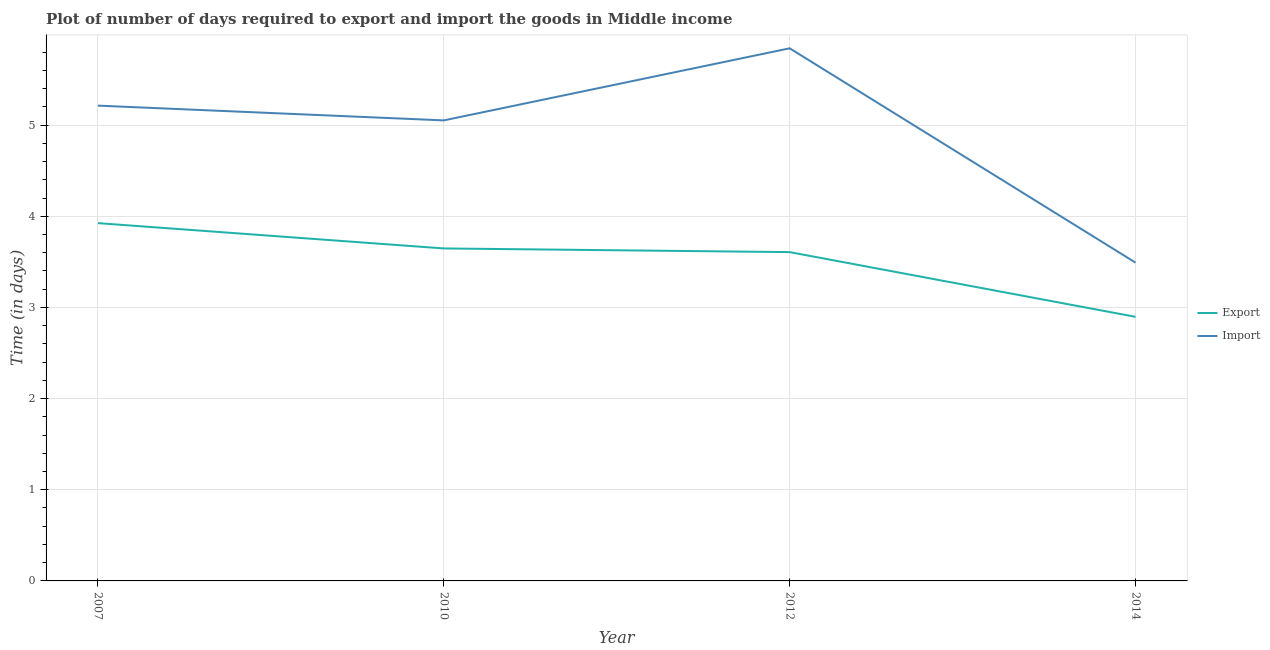How many different coloured lines are there?
Offer a terse response. 2. Is the number of lines equal to the number of legend labels?
Provide a succinct answer. Yes. What is the time required to import in 2010?
Give a very brief answer. 5.05. Across all years, what is the maximum time required to export?
Offer a very short reply. 3.92. Across all years, what is the minimum time required to export?
Offer a very short reply. 2.9. In which year was the time required to import maximum?
Offer a terse response. 2012. In which year was the time required to export minimum?
Make the answer very short. 2014. What is the total time required to export in the graph?
Ensure brevity in your answer.  14.07. What is the difference between the time required to export in 2007 and that in 2010?
Provide a succinct answer. 0.28. What is the difference between the time required to export in 2014 and the time required to import in 2010?
Your answer should be compact. -2.15. What is the average time required to import per year?
Keep it short and to the point. 4.9. In the year 2012, what is the difference between the time required to export and time required to import?
Ensure brevity in your answer.  -2.24. What is the ratio of the time required to export in 2007 to that in 2012?
Your answer should be compact. 1.09. Is the time required to import in 2010 less than that in 2012?
Keep it short and to the point. Yes. What is the difference between the highest and the second highest time required to import?
Make the answer very short. 0.63. What is the difference between the highest and the lowest time required to import?
Your response must be concise. 2.35. Is the time required to export strictly greater than the time required to import over the years?
Provide a short and direct response. No. Is the time required to export strictly less than the time required to import over the years?
Make the answer very short. Yes. How many lines are there?
Offer a very short reply. 2. What is the difference between two consecutive major ticks on the Y-axis?
Your answer should be very brief. 1. Are the values on the major ticks of Y-axis written in scientific E-notation?
Provide a short and direct response. No. Does the graph contain any zero values?
Ensure brevity in your answer.  No. Where does the legend appear in the graph?
Your answer should be compact. Center right. How many legend labels are there?
Offer a very short reply. 2. How are the legend labels stacked?
Offer a very short reply. Vertical. What is the title of the graph?
Your answer should be very brief. Plot of number of days required to export and import the goods in Middle income. What is the label or title of the X-axis?
Provide a short and direct response. Year. What is the label or title of the Y-axis?
Keep it short and to the point. Time (in days). What is the Time (in days) in Export in 2007?
Give a very brief answer. 3.92. What is the Time (in days) in Import in 2007?
Your answer should be very brief. 5.21. What is the Time (in days) in Export in 2010?
Make the answer very short. 3.65. What is the Time (in days) in Import in 2010?
Make the answer very short. 5.05. What is the Time (in days) in Export in 2012?
Your response must be concise. 3.61. What is the Time (in days) of Import in 2012?
Keep it short and to the point. 5.84. What is the Time (in days) of Export in 2014?
Your answer should be very brief. 2.9. What is the Time (in days) of Import in 2014?
Your response must be concise. 3.49. Across all years, what is the maximum Time (in days) in Export?
Ensure brevity in your answer.  3.92. Across all years, what is the maximum Time (in days) of Import?
Your response must be concise. 5.84. Across all years, what is the minimum Time (in days) in Export?
Ensure brevity in your answer.  2.9. Across all years, what is the minimum Time (in days) in Import?
Provide a short and direct response. 3.49. What is the total Time (in days) of Export in the graph?
Provide a short and direct response. 14.07. What is the total Time (in days) of Import in the graph?
Provide a short and direct response. 19.6. What is the difference between the Time (in days) of Export in 2007 and that in 2010?
Make the answer very short. 0.28. What is the difference between the Time (in days) in Import in 2007 and that in 2010?
Your answer should be compact. 0.16. What is the difference between the Time (in days) in Export in 2007 and that in 2012?
Offer a terse response. 0.32. What is the difference between the Time (in days) of Import in 2007 and that in 2012?
Give a very brief answer. -0.63. What is the difference between the Time (in days) of Export in 2007 and that in 2014?
Provide a succinct answer. 1.03. What is the difference between the Time (in days) in Import in 2007 and that in 2014?
Give a very brief answer. 1.72. What is the difference between the Time (in days) in Export in 2010 and that in 2012?
Provide a short and direct response. 0.04. What is the difference between the Time (in days) in Import in 2010 and that in 2012?
Make the answer very short. -0.79. What is the difference between the Time (in days) of Export in 2010 and that in 2014?
Offer a terse response. 0.75. What is the difference between the Time (in days) in Import in 2010 and that in 2014?
Offer a terse response. 1.56. What is the difference between the Time (in days) in Export in 2012 and that in 2014?
Provide a short and direct response. 0.71. What is the difference between the Time (in days) of Import in 2012 and that in 2014?
Your response must be concise. 2.35. What is the difference between the Time (in days) in Export in 2007 and the Time (in days) in Import in 2010?
Your answer should be very brief. -1.13. What is the difference between the Time (in days) of Export in 2007 and the Time (in days) of Import in 2012?
Provide a short and direct response. -1.92. What is the difference between the Time (in days) in Export in 2007 and the Time (in days) in Import in 2014?
Your response must be concise. 0.43. What is the difference between the Time (in days) of Export in 2010 and the Time (in days) of Import in 2012?
Provide a succinct answer. -2.2. What is the difference between the Time (in days) in Export in 2010 and the Time (in days) in Import in 2014?
Your answer should be very brief. 0.16. What is the difference between the Time (in days) of Export in 2012 and the Time (in days) of Import in 2014?
Give a very brief answer. 0.12. What is the average Time (in days) of Export per year?
Ensure brevity in your answer.  3.52. What is the average Time (in days) in Import per year?
Ensure brevity in your answer.  4.9. In the year 2007, what is the difference between the Time (in days) of Export and Time (in days) of Import?
Make the answer very short. -1.29. In the year 2010, what is the difference between the Time (in days) of Export and Time (in days) of Import?
Provide a short and direct response. -1.4. In the year 2012, what is the difference between the Time (in days) of Export and Time (in days) of Import?
Give a very brief answer. -2.24. In the year 2014, what is the difference between the Time (in days) in Export and Time (in days) in Import?
Offer a very short reply. -0.59. What is the ratio of the Time (in days) of Export in 2007 to that in 2010?
Provide a short and direct response. 1.08. What is the ratio of the Time (in days) in Import in 2007 to that in 2010?
Make the answer very short. 1.03. What is the ratio of the Time (in days) in Export in 2007 to that in 2012?
Make the answer very short. 1.09. What is the ratio of the Time (in days) of Import in 2007 to that in 2012?
Ensure brevity in your answer.  0.89. What is the ratio of the Time (in days) of Export in 2007 to that in 2014?
Provide a short and direct response. 1.35. What is the ratio of the Time (in days) in Import in 2007 to that in 2014?
Give a very brief answer. 1.49. What is the ratio of the Time (in days) in Export in 2010 to that in 2012?
Provide a short and direct response. 1.01. What is the ratio of the Time (in days) of Import in 2010 to that in 2012?
Your response must be concise. 0.86. What is the ratio of the Time (in days) in Export in 2010 to that in 2014?
Provide a short and direct response. 1.26. What is the ratio of the Time (in days) in Import in 2010 to that in 2014?
Provide a succinct answer. 1.45. What is the ratio of the Time (in days) in Export in 2012 to that in 2014?
Offer a very short reply. 1.25. What is the ratio of the Time (in days) in Import in 2012 to that in 2014?
Keep it short and to the point. 1.67. What is the difference between the highest and the second highest Time (in days) of Export?
Provide a short and direct response. 0.28. What is the difference between the highest and the second highest Time (in days) in Import?
Your answer should be very brief. 0.63. What is the difference between the highest and the lowest Time (in days) of Export?
Your response must be concise. 1.03. What is the difference between the highest and the lowest Time (in days) of Import?
Ensure brevity in your answer.  2.35. 